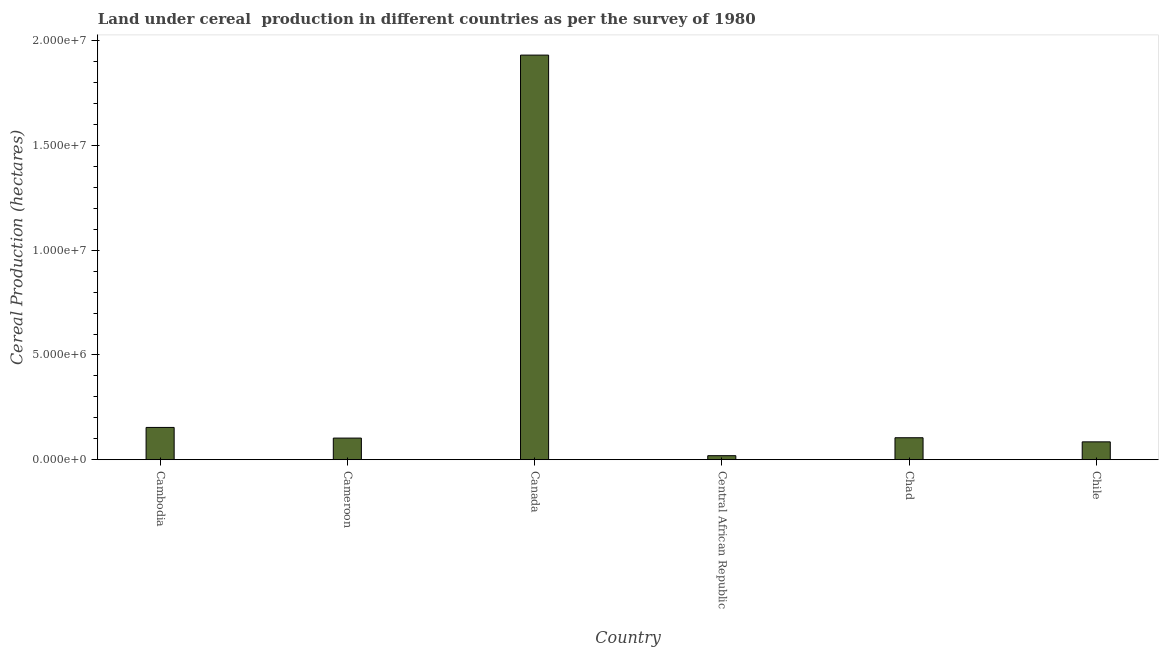What is the title of the graph?
Your answer should be very brief. Land under cereal  production in different countries as per the survey of 1980. What is the label or title of the Y-axis?
Offer a terse response. Cereal Production (hectares). What is the land under cereal production in Canada?
Offer a very short reply. 1.93e+07. Across all countries, what is the maximum land under cereal production?
Ensure brevity in your answer.  1.93e+07. Across all countries, what is the minimum land under cereal production?
Your answer should be compact. 1.92e+05. In which country was the land under cereal production maximum?
Keep it short and to the point. Canada. In which country was the land under cereal production minimum?
Provide a succinct answer. Central African Republic. What is the sum of the land under cereal production?
Keep it short and to the point. 2.40e+07. What is the difference between the land under cereal production in Canada and Chad?
Give a very brief answer. 1.83e+07. What is the average land under cereal production per country?
Your answer should be compact. 4.00e+06. What is the median land under cereal production?
Make the answer very short. 1.04e+06. In how many countries, is the land under cereal production greater than 16000000 hectares?
Ensure brevity in your answer.  1. What is the ratio of the land under cereal production in Cameroon to that in Chile?
Your answer should be compact. 1.21. What is the difference between the highest and the second highest land under cereal production?
Provide a succinct answer. 1.78e+07. Is the sum of the land under cereal production in Cameroon and Central African Republic greater than the maximum land under cereal production across all countries?
Offer a very short reply. No. What is the difference between the highest and the lowest land under cereal production?
Offer a terse response. 1.91e+07. In how many countries, is the land under cereal production greater than the average land under cereal production taken over all countries?
Make the answer very short. 1. How many countries are there in the graph?
Provide a short and direct response. 6. What is the Cereal Production (hectares) in Cambodia?
Provide a succinct answer. 1.54e+06. What is the Cereal Production (hectares) of Cameroon?
Keep it short and to the point. 1.03e+06. What is the Cereal Production (hectares) in Canada?
Keep it short and to the point. 1.93e+07. What is the Cereal Production (hectares) in Central African Republic?
Offer a terse response. 1.92e+05. What is the Cereal Production (hectares) of Chad?
Give a very brief answer. 1.05e+06. What is the Cereal Production (hectares) in Chile?
Ensure brevity in your answer.  8.52e+05. What is the difference between the Cereal Production (hectares) in Cambodia and Cameroon?
Your response must be concise. 5.09e+05. What is the difference between the Cereal Production (hectares) in Cambodia and Canada?
Your response must be concise. -1.78e+07. What is the difference between the Cereal Production (hectares) in Cambodia and Central African Republic?
Keep it short and to the point. 1.35e+06. What is the difference between the Cereal Production (hectares) in Cambodia and Chad?
Ensure brevity in your answer.  4.93e+05. What is the difference between the Cereal Production (hectares) in Cambodia and Chile?
Provide a succinct answer. 6.89e+05. What is the difference between the Cereal Production (hectares) in Cameroon and Canada?
Ensure brevity in your answer.  -1.83e+07. What is the difference between the Cereal Production (hectares) in Cameroon and Central African Republic?
Your answer should be compact. 8.40e+05. What is the difference between the Cereal Production (hectares) in Cameroon and Chad?
Offer a terse response. -1.63e+04. What is the difference between the Cereal Production (hectares) in Cameroon and Chile?
Offer a very short reply. 1.80e+05. What is the difference between the Cereal Production (hectares) in Canada and Central African Republic?
Keep it short and to the point. 1.91e+07. What is the difference between the Cereal Production (hectares) in Canada and Chad?
Provide a short and direct response. 1.83e+07. What is the difference between the Cereal Production (hectares) in Canada and Chile?
Your response must be concise. 1.85e+07. What is the difference between the Cereal Production (hectares) in Central African Republic and Chad?
Provide a short and direct response. -8.56e+05. What is the difference between the Cereal Production (hectares) in Central African Republic and Chile?
Make the answer very short. -6.60e+05. What is the difference between the Cereal Production (hectares) in Chad and Chile?
Your response must be concise. 1.96e+05. What is the ratio of the Cereal Production (hectares) in Cambodia to that in Cameroon?
Give a very brief answer. 1.49. What is the ratio of the Cereal Production (hectares) in Cambodia to that in Canada?
Offer a terse response. 0.08. What is the ratio of the Cereal Production (hectares) in Cambodia to that in Central African Republic?
Your response must be concise. 8.04. What is the ratio of the Cereal Production (hectares) in Cambodia to that in Chad?
Ensure brevity in your answer.  1.47. What is the ratio of the Cereal Production (hectares) in Cambodia to that in Chile?
Make the answer very short. 1.81. What is the ratio of the Cereal Production (hectares) in Cameroon to that in Canada?
Make the answer very short. 0.05. What is the ratio of the Cereal Production (hectares) in Cameroon to that in Central African Republic?
Your answer should be very brief. 5.38. What is the ratio of the Cereal Production (hectares) in Cameroon to that in Chile?
Your answer should be very brief. 1.21. What is the ratio of the Cereal Production (hectares) in Canada to that in Central African Republic?
Offer a terse response. 100.8. What is the ratio of the Cereal Production (hectares) in Canada to that in Chad?
Your answer should be compact. 18.43. What is the ratio of the Cereal Production (hectares) in Canada to that in Chile?
Your response must be concise. 22.67. What is the ratio of the Cereal Production (hectares) in Central African Republic to that in Chad?
Your answer should be compact. 0.18. What is the ratio of the Cereal Production (hectares) in Central African Republic to that in Chile?
Provide a succinct answer. 0.23. What is the ratio of the Cereal Production (hectares) in Chad to that in Chile?
Make the answer very short. 1.23. 